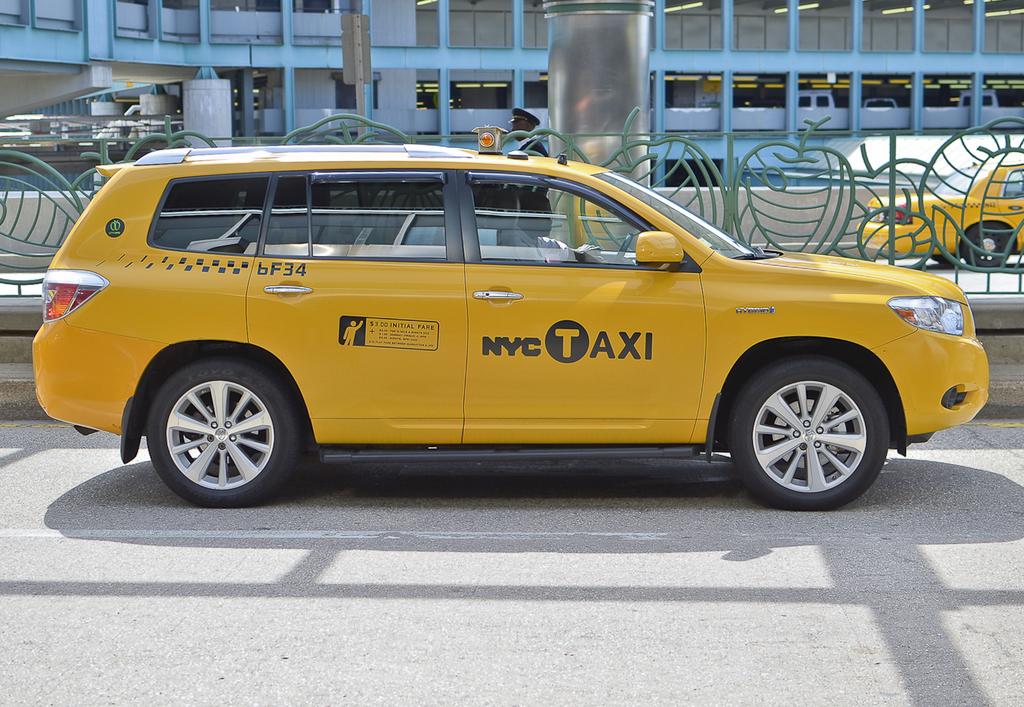What city is this taxi in?
Keep it short and to the point. Nyc. What does it say on the side of the car?
Offer a terse response. Nyc taxi. 